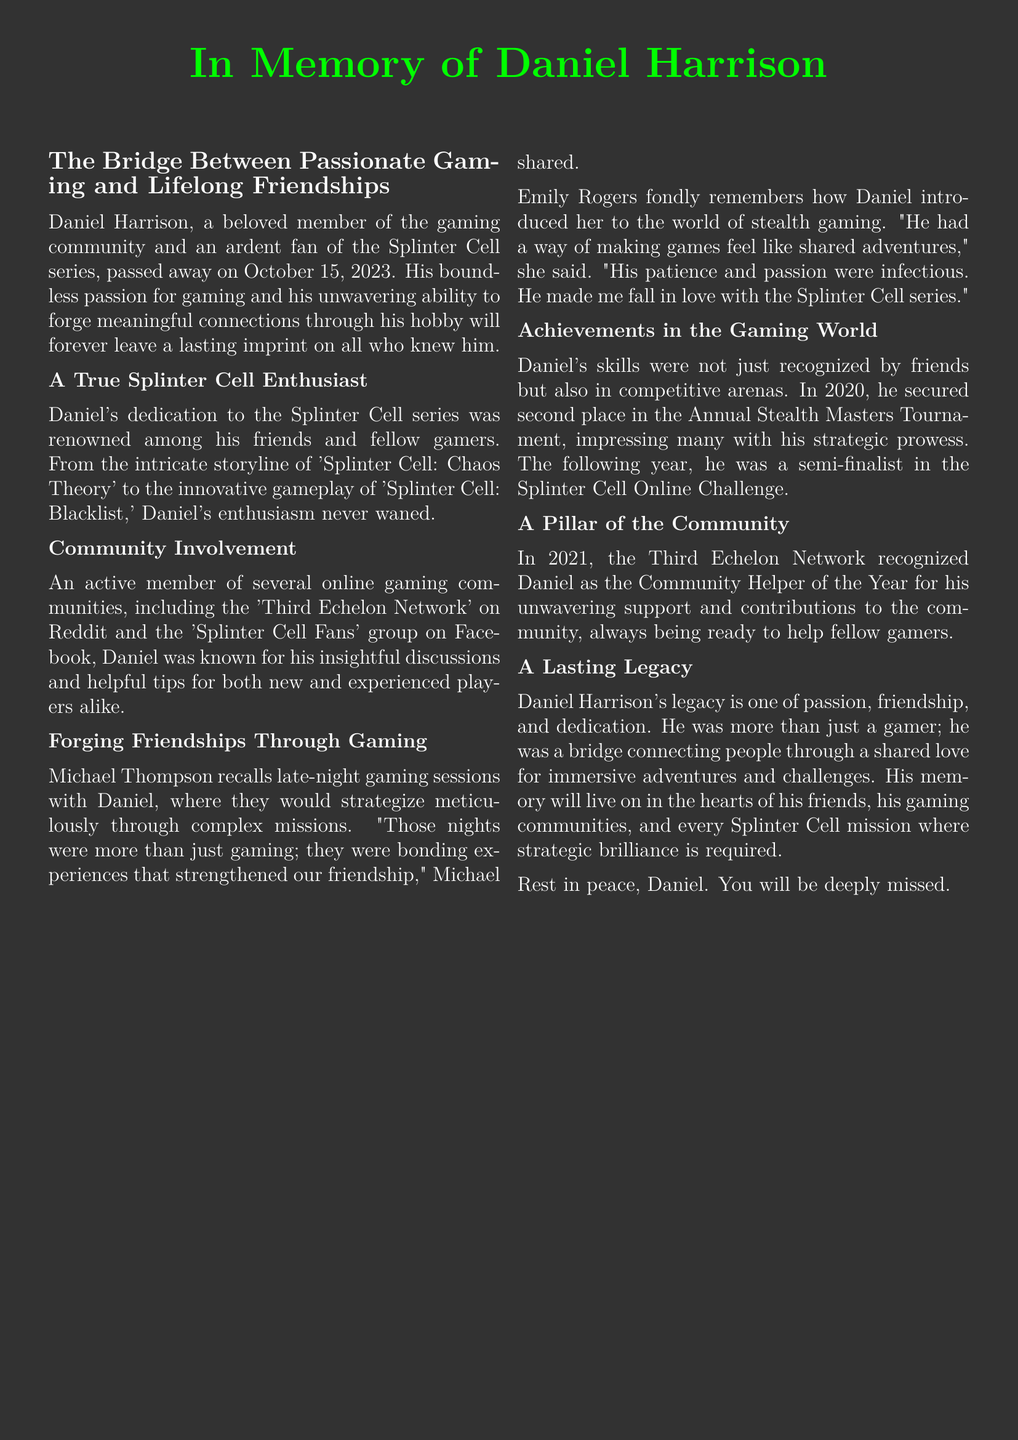What is the name of the person being remembered? The document honors and remembers Daniel Harrison.
Answer: Daniel Harrison What date did Daniel Harrison pass away? The document indicates that he passed away on October 15, 2023.
Answer: October 15, 2023 Which gaming series was Daniel passionate about? The content mentions that Daniel was an ardent fan of the Splinter Cell series.
Answer: Splinter Cell What place did Daniel secure in the Annual Stealth Masters Tournament in 2020? The document states that he secured second place in the tournament.
Answer: Second place Who recognized Daniel as the Community Helper of the Year? The Third Echelon Network recognized Daniel for his contributions.
Answer: Third Echelon Network What type of gaming sessions does Michael Thompson recall with Daniel? Michael reflects on late-night gaming sessions where they would strategize.
Answer: Late-night gaming sessions What quality of Daniel's helped forge friendships through gaming? The document emphasizes his patience and passion in gaming that made shared adventures enjoyable.
Answer: Patience and passion In what competitive event was Daniel a semi-finalist in 2021? The document mentions he was a semi-finalist in the Splinter Cell Online Challenge.
Answer: Splinter Cell Online Challenge What was Daniel’s legacy described as? The document describes his legacy as one of passion, friendship, and dedication.
Answer: Passion, friendship, and dedication 